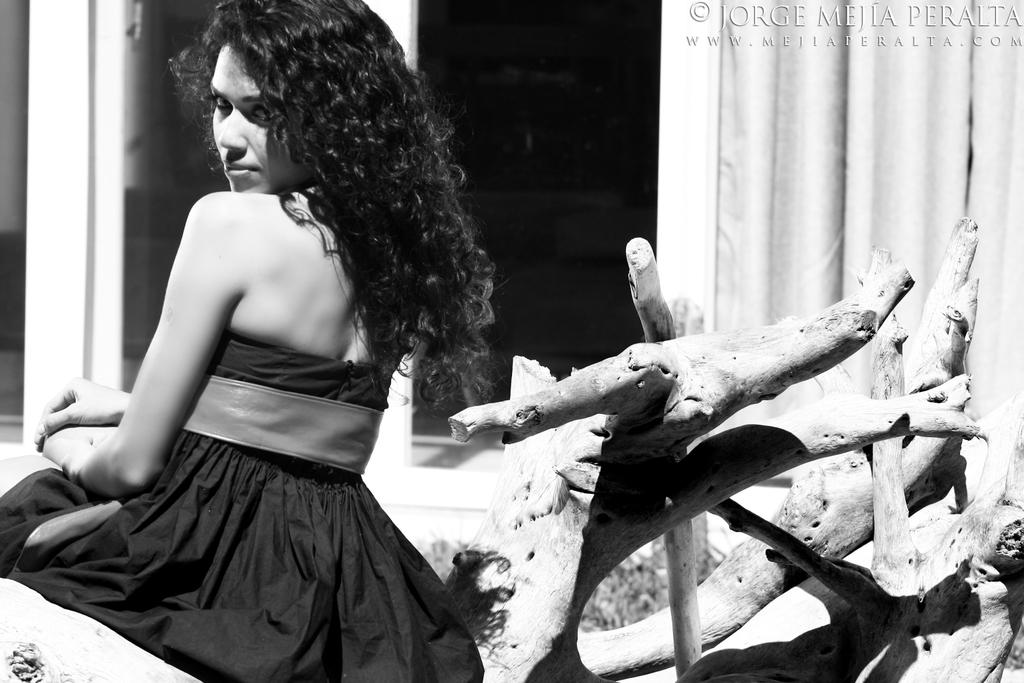Who is the main subject in the image? There is a lady in the image. Where is the lady located in the image? The lady is sitting on the left side of the image. What is the lady wearing? The lady is wearing a black dress. What is the lady sitting on? The lady is sitting on a wooden surface. What can be seen in the background of the image? There are curtains in the background of the image. How many pigs are visible in the image? There are no pigs present in the image. What type of dirt can be seen on the lady's dress in the image? There is no dirt visible on the lady's dress in the image. 